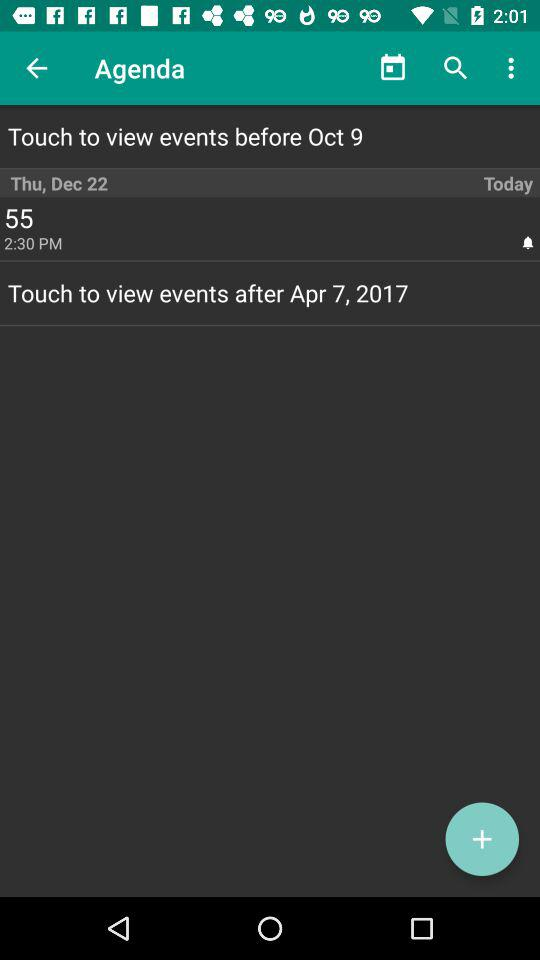On which date is "event 55" scheduled? The date of "event 55" is scheduled for Thursday, December 22. 